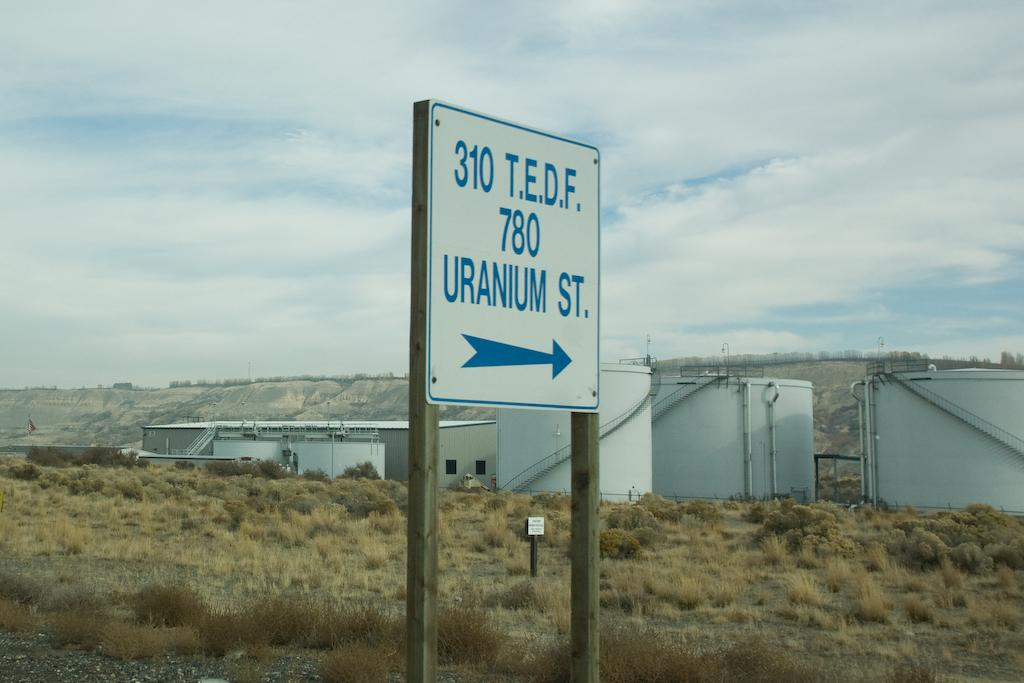<image>
Summarize the visual content of the image. a sign that has the number 310 on it 